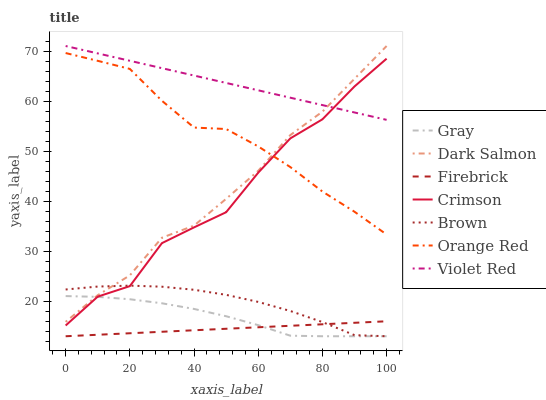Does Firebrick have the minimum area under the curve?
Answer yes or no. Yes. Does Violet Red have the maximum area under the curve?
Answer yes or no. Yes. Does Brown have the minimum area under the curve?
Answer yes or no. No. Does Brown have the maximum area under the curve?
Answer yes or no. No. Is Firebrick the smoothest?
Answer yes or no. Yes. Is Crimson the roughest?
Answer yes or no. Yes. Is Violet Red the smoothest?
Answer yes or no. No. Is Violet Red the roughest?
Answer yes or no. No. Does Gray have the lowest value?
Answer yes or no. Yes. Does Violet Red have the lowest value?
Answer yes or no. No. Does Dark Salmon have the highest value?
Answer yes or no. Yes. Does Brown have the highest value?
Answer yes or no. No. Is Firebrick less than Violet Red?
Answer yes or no. Yes. Is Violet Red greater than Brown?
Answer yes or no. Yes. Does Dark Salmon intersect Brown?
Answer yes or no. Yes. Is Dark Salmon less than Brown?
Answer yes or no. No. Is Dark Salmon greater than Brown?
Answer yes or no. No. Does Firebrick intersect Violet Red?
Answer yes or no. No. 